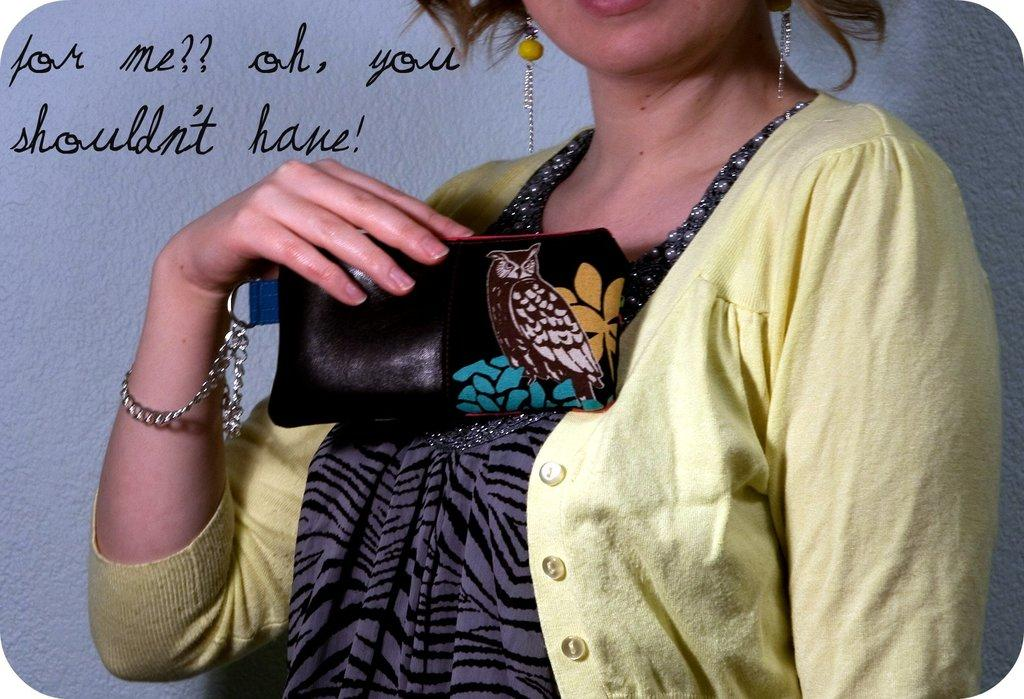Who is present in the image? There is a woman in the image. What is the woman holding in the image? The woman is holding a wallet. What can be seen on the left side of the image? There is text on the left side of the image. What is visible in the background of the image? There is a well visible behind the woman. How many horses are present in the image? There are no horses present in the image. What type of harmony is being exchanged between the woman and the well in the image? There is no exchange of harmony between the woman and the well in the image; the well is simply a background element. 